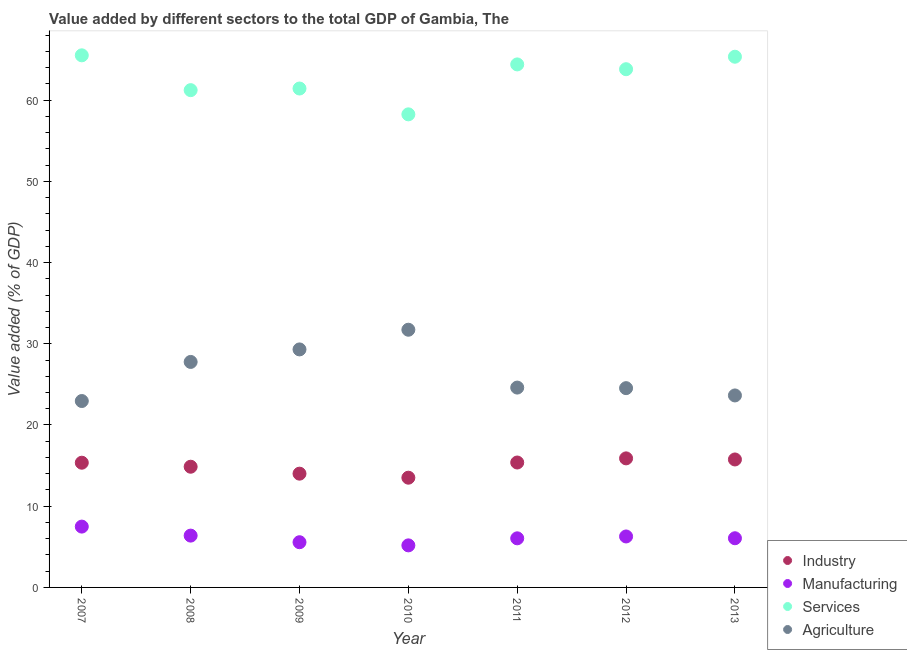Is the number of dotlines equal to the number of legend labels?
Provide a succinct answer. Yes. What is the value added by manufacturing sector in 2012?
Keep it short and to the point. 6.27. Across all years, what is the maximum value added by services sector?
Provide a short and direct response. 65.51. Across all years, what is the minimum value added by agricultural sector?
Your answer should be very brief. 22.95. In which year was the value added by industrial sector maximum?
Your response must be concise. 2012. In which year was the value added by services sector minimum?
Keep it short and to the point. 2010. What is the total value added by manufacturing sector in the graph?
Make the answer very short. 42.99. What is the difference between the value added by agricultural sector in 2011 and that in 2012?
Your answer should be compact. 0.07. What is the difference between the value added by services sector in 2013 and the value added by agricultural sector in 2009?
Offer a terse response. 36.04. What is the average value added by agricultural sector per year?
Your response must be concise. 26.36. In the year 2012, what is the difference between the value added by services sector and value added by agricultural sector?
Provide a short and direct response. 39.27. What is the ratio of the value added by services sector in 2008 to that in 2009?
Provide a succinct answer. 1. Is the difference between the value added by agricultural sector in 2008 and 2010 greater than the difference between the value added by services sector in 2008 and 2010?
Ensure brevity in your answer.  No. What is the difference between the highest and the second highest value added by services sector?
Offer a very short reply. 0.17. What is the difference between the highest and the lowest value added by manufacturing sector?
Ensure brevity in your answer.  2.31. In how many years, is the value added by industrial sector greater than the average value added by industrial sector taken over all years?
Your answer should be compact. 4. Is the sum of the value added by agricultural sector in 2008 and 2009 greater than the maximum value added by industrial sector across all years?
Provide a succinct answer. Yes. Is it the case that in every year, the sum of the value added by services sector and value added by industrial sector is greater than the sum of value added by agricultural sector and value added by manufacturing sector?
Your answer should be very brief. No. Does the value added by agricultural sector monotonically increase over the years?
Keep it short and to the point. No. How many dotlines are there?
Make the answer very short. 4. What is the difference between two consecutive major ticks on the Y-axis?
Your response must be concise. 10. Are the values on the major ticks of Y-axis written in scientific E-notation?
Your answer should be compact. No. What is the title of the graph?
Make the answer very short. Value added by different sectors to the total GDP of Gambia, The. What is the label or title of the Y-axis?
Your answer should be very brief. Value added (% of GDP). What is the Value added (% of GDP) of Industry in 2007?
Provide a short and direct response. 15.35. What is the Value added (% of GDP) in Manufacturing in 2007?
Make the answer very short. 7.49. What is the Value added (% of GDP) in Services in 2007?
Provide a succinct answer. 65.51. What is the Value added (% of GDP) in Agriculture in 2007?
Your response must be concise. 22.95. What is the Value added (% of GDP) of Industry in 2008?
Provide a succinct answer. 14.86. What is the Value added (% of GDP) of Manufacturing in 2008?
Your response must be concise. 6.38. What is the Value added (% of GDP) in Services in 2008?
Provide a succinct answer. 61.23. What is the Value added (% of GDP) of Agriculture in 2008?
Keep it short and to the point. 27.76. What is the Value added (% of GDP) in Industry in 2009?
Provide a short and direct response. 14.01. What is the Value added (% of GDP) in Manufacturing in 2009?
Provide a succinct answer. 5.57. What is the Value added (% of GDP) in Services in 2009?
Provide a short and direct response. 61.43. What is the Value added (% of GDP) of Agriculture in 2009?
Your response must be concise. 29.3. What is the Value added (% of GDP) in Industry in 2010?
Give a very brief answer. 13.51. What is the Value added (% of GDP) in Manufacturing in 2010?
Keep it short and to the point. 5.18. What is the Value added (% of GDP) in Services in 2010?
Offer a very short reply. 58.25. What is the Value added (% of GDP) of Agriculture in 2010?
Your response must be concise. 31.73. What is the Value added (% of GDP) in Industry in 2011?
Your response must be concise. 15.38. What is the Value added (% of GDP) in Manufacturing in 2011?
Your answer should be compact. 6.05. What is the Value added (% of GDP) in Services in 2011?
Offer a very short reply. 64.39. What is the Value added (% of GDP) of Agriculture in 2011?
Provide a succinct answer. 24.61. What is the Value added (% of GDP) of Industry in 2012?
Your response must be concise. 15.89. What is the Value added (% of GDP) of Manufacturing in 2012?
Offer a terse response. 6.27. What is the Value added (% of GDP) in Services in 2012?
Ensure brevity in your answer.  63.8. What is the Value added (% of GDP) in Agriculture in 2012?
Provide a short and direct response. 24.54. What is the Value added (% of GDP) of Industry in 2013?
Give a very brief answer. 15.75. What is the Value added (% of GDP) of Manufacturing in 2013?
Your answer should be very brief. 6.05. What is the Value added (% of GDP) of Services in 2013?
Your answer should be very brief. 65.34. What is the Value added (% of GDP) in Agriculture in 2013?
Keep it short and to the point. 23.64. Across all years, what is the maximum Value added (% of GDP) in Industry?
Your response must be concise. 15.89. Across all years, what is the maximum Value added (% of GDP) of Manufacturing?
Provide a succinct answer. 7.49. Across all years, what is the maximum Value added (% of GDP) of Services?
Offer a terse response. 65.51. Across all years, what is the maximum Value added (% of GDP) of Agriculture?
Make the answer very short. 31.73. Across all years, what is the minimum Value added (% of GDP) of Industry?
Your answer should be compact. 13.51. Across all years, what is the minimum Value added (% of GDP) in Manufacturing?
Offer a very short reply. 5.18. Across all years, what is the minimum Value added (% of GDP) of Services?
Ensure brevity in your answer.  58.25. Across all years, what is the minimum Value added (% of GDP) in Agriculture?
Make the answer very short. 22.95. What is the total Value added (% of GDP) of Industry in the graph?
Give a very brief answer. 104.76. What is the total Value added (% of GDP) of Manufacturing in the graph?
Provide a short and direct response. 42.99. What is the total Value added (% of GDP) of Services in the graph?
Your answer should be compact. 439.95. What is the total Value added (% of GDP) of Agriculture in the graph?
Keep it short and to the point. 184.52. What is the difference between the Value added (% of GDP) in Industry in 2007 and that in 2008?
Keep it short and to the point. 0.49. What is the difference between the Value added (% of GDP) of Manufacturing in 2007 and that in 2008?
Ensure brevity in your answer.  1.11. What is the difference between the Value added (% of GDP) in Services in 2007 and that in 2008?
Your answer should be very brief. 4.29. What is the difference between the Value added (% of GDP) in Agriculture in 2007 and that in 2008?
Provide a succinct answer. -4.81. What is the difference between the Value added (% of GDP) in Industry in 2007 and that in 2009?
Make the answer very short. 1.35. What is the difference between the Value added (% of GDP) of Manufacturing in 2007 and that in 2009?
Keep it short and to the point. 1.92. What is the difference between the Value added (% of GDP) in Services in 2007 and that in 2009?
Your answer should be compact. 4.09. What is the difference between the Value added (% of GDP) in Agriculture in 2007 and that in 2009?
Provide a succinct answer. -6.35. What is the difference between the Value added (% of GDP) of Industry in 2007 and that in 2010?
Make the answer very short. 1.84. What is the difference between the Value added (% of GDP) of Manufacturing in 2007 and that in 2010?
Keep it short and to the point. 2.31. What is the difference between the Value added (% of GDP) in Services in 2007 and that in 2010?
Your answer should be very brief. 7.27. What is the difference between the Value added (% of GDP) of Agriculture in 2007 and that in 2010?
Offer a terse response. -8.78. What is the difference between the Value added (% of GDP) of Industry in 2007 and that in 2011?
Provide a succinct answer. -0.03. What is the difference between the Value added (% of GDP) in Manufacturing in 2007 and that in 2011?
Keep it short and to the point. 1.44. What is the difference between the Value added (% of GDP) in Services in 2007 and that in 2011?
Ensure brevity in your answer.  1.12. What is the difference between the Value added (% of GDP) of Agriculture in 2007 and that in 2011?
Your response must be concise. -1.66. What is the difference between the Value added (% of GDP) of Industry in 2007 and that in 2012?
Ensure brevity in your answer.  -0.53. What is the difference between the Value added (% of GDP) of Manufacturing in 2007 and that in 2012?
Your response must be concise. 1.21. What is the difference between the Value added (% of GDP) in Services in 2007 and that in 2012?
Offer a terse response. 1.71. What is the difference between the Value added (% of GDP) of Agriculture in 2007 and that in 2012?
Offer a terse response. -1.59. What is the difference between the Value added (% of GDP) of Manufacturing in 2007 and that in 2013?
Give a very brief answer. 1.43. What is the difference between the Value added (% of GDP) of Services in 2007 and that in 2013?
Your answer should be compact. 0.17. What is the difference between the Value added (% of GDP) of Agriculture in 2007 and that in 2013?
Ensure brevity in your answer.  -0.69. What is the difference between the Value added (% of GDP) in Industry in 2008 and that in 2009?
Provide a short and direct response. 0.85. What is the difference between the Value added (% of GDP) in Manufacturing in 2008 and that in 2009?
Make the answer very short. 0.81. What is the difference between the Value added (% of GDP) of Services in 2008 and that in 2009?
Provide a succinct answer. -0.2. What is the difference between the Value added (% of GDP) in Agriculture in 2008 and that in 2009?
Your answer should be compact. -1.54. What is the difference between the Value added (% of GDP) of Industry in 2008 and that in 2010?
Your answer should be very brief. 1.35. What is the difference between the Value added (% of GDP) of Manufacturing in 2008 and that in 2010?
Your answer should be compact. 1.2. What is the difference between the Value added (% of GDP) in Services in 2008 and that in 2010?
Your answer should be very brief. 2.98. What is the difference between the Value added (% of GDP) of Agriculture in 2008 and that in 2010?
Your answer should be compact. -3.96. What is the difference between the Value added (% of GDP) in Industry in 2008 and that in 2011?
Provide a succinct answer. -0.52. What is the difference between the Value added (% of GDP) of Manufacturing in 2008 and that in 2011?
Make the answer very short. 0.33. What is the difference between the Value added (% of GDP) in Services in 2008 and that in 2011?
Your answer should be compact. -3.17. What is the difference between the Value added (% of GDP) in Agriculture in 2008 and that in 2011?
Your response must be concise. 3.16. What is the difference between the Value added (% of GDP) in Industry in 2008 and that in 2012?
Ensure brevity in your answer.  -1.03. What is the difference between the Value added (% of GDP) in Manufacturing in 2008 and that in 2012?
Give a very brief answer. 0.1. What is the difference between the Value added (% of GDP) in Services in 2008 and that in 2012?
Offer a very short reply. -2.58. What is the difference between the Value added (% of GDP) in Agriculture in 2008 and that in 2012?
Your answer should be very brief. 3.23. What is the difference between the Value added (% of GDP) in Industry in 2008 and that in 2013?
Your response must be concise. -0.89. What is the difference between the Value added (% of GDP) in Manufacturing in 2008 and that in 2013?
Your answer should be compact. 0.32. What is the difference between the Value added (% of GDP) of Services in 2008 and that in 2013?
Your answer should be compact. -4.11. What is the difference between the Value added (% of GDP) in Agriculture in 2008 and that in 2013?
Provide a succinct answer. 4.13. What is the difference between the Value added (% of GDP) of Industry in 2009 and that in 2010?
Give a very brief answer. 0.5. What is the difference between the Value added (% of GDP) in Manufacturing in 2009 and that in 2010?
Offer a very short reply. 0.39. What is the difference between the Value added (% of GDP) in Services in 2009 and that in 2010?
Your answer should be compact. 3.18. What is the difference between the Value added (% of GDP) of Agriculture in 2009 and that in 2010?
Give a very brief answer. -2.42. What is the difference between the Value added (% of GDP) of Industry in 2009 and that in 2011?
Provide a succinct answer. -1.37. What is the difference between the Value added (% of GDP) of Manufacturing in 2009 and that in 2011?
Provide a short and direct response. -0.48. What is the difference between the Value added (% of GDP) in Services in 2009 and that in 2011?
Offer a very short reply. -2.97. What is the difference between the Value added (% of GDP) in Agriculture in 2009 and that in 2011?
Your response must be concise. 4.7. What is the difference between the Value added (% of GDP) in Industry in 2009 and that in 2012?
Provide a succinct answer. -1.88. What is the difference between the Value added (% of GDP) in Manufacturing in 2009 and that in 2012?
Ensure brevity in your answer.  -0.71. What is the difference between the Value added (% of GDP) of Services in 2009 and that in 2012?
Give a very brief answer. -2.38. What is the difference between the Value added (% of GDP) in Agriculture in 2009 and that in 2012?
Your answer should be very brief. 4.77. What is the difference between the Value added (% of GDP) in Industry in 2009 and that in 2013?
Offer a very short reply. -1.75. What is the difference between the Value added (% of GDP) of Manufacturing in 2009 and that in 2013?
Offer a very short reply. -0.49. What is the difference between the Value added (% of GDP) in Services in 2009 and that in 2013?
Ensure brevity in your answer.  -3.91. What is the difference between the Value added (% of GDP) in Agriculture in 2009 and that in 2013?
Offer a very short reply. 5.67. What is the difference between the Value added (% of GDP) of Industry in 2010 and that in 2011?
Offer a terse response. -1.87. What is the difference between the Value added (% of GDP) in Manufacturing in 2010 and that in 2011?
Provide a short and direct response. -0.87. What is the difference between the Value added (% of GDP) of Services in 2010 and that in 2011?
Offer a very short reply. -6.15. What is the difference between the Value added (% of GDP) in Agriculture in 2010 and that in 2011?
Offer a very short reply. 7.12. What is the difference between the Value added (% of GDP) in Industry in 2010 and that in 2012?
Your response must be concise. -2.38. What is the difference between the Value added (% of GDP) in Manufacturing in 2010 and that in 2012?
Keep it short and to the point. -1.1. What is the difference between the Value added (% of GDP) of Services in 2010 and that in 2012?
Your answer should be compact. -5.56. What is the difference between the Value added (% of GDP) of Agriculture in 2010 and that in 2012?
Offer a very short reply. 7.19. What is the difference between the Value added (% of GDP) in Industry in 2010 and that in 2013?
Offer a terse response. -2.24. What is the difference between the Value added (% of GDP) in Manufacturing in 2010 and that in 2013?
Provide a short and direct response. -0.88. What is the difference between the Value added (% of GDP) of Services in 2010 and that in 2013?
Make the answer very short. -7.09. What is the difference between the Value added (% of GDP) of Agriculture in 2010 and that in 2013?
Offer a very short reply. 8.09. What is the difference between the Value added (% of GDP) of Industry in 2011 and that in 2012?
Provide a succinct answer. -0.51. What is the difference between the Value added (% of GDP) of Manufacturing in 2011 and that in 2012?
Make the answer very short. -0.23. What is the difference between the Value added (% of GDP) of Services in 2011 and that in 2012?
Provide a short and direct response. 0.59. What is the difference between the Value added (% of GDP) in Agriculture in 2011 and that in 2012?
Your answer should be very brief. 0.07. What is the difference between the Value added (% of GDP) of Industry in 2011 and that in 2013?
Provide a succinct answer. -0.37. What is the difference between the Value added (% of GDP) in Manufacturing in 2011 and that in 2013?
Offer a terse response. -0.01. What is the difference between the Value added (% of GDP) of Services in 2011 and that in 2013?
Make the answer very short. -0.95. What is the difference between the Value added (% of GDP) of Agriculture in 2011 and that in 2013?
Give a very brief answer. 0.97. What is the difference between the Value added (% of GDP) of Industry in 2012 and that in 2013?
Your response must be concise. 0.13. What is the difference between the Value added (% of GDP) of Manufacturing in 2012 and that in 2013?
Your answer should be compact. 0.22. What is the difference between the Value added (% of GDP) in Services in 2012 and that in 2013?
Provide a short and direct response. -1.54. What is the difference between the Value added (% of GDP) of Agriculture in 2012 and that in 2013?
Provide a succinct answer. 0.9. What is the difference between the Value added (% of GDP) of Industry in 2007 and the Value added (% of GDP) of Manufacturing in 2008?
Your answer should be very brief. 8.98. What is the difference between the Value added (% of GDP) of Industry in 2007 and the Value added (% of GDP) of Services in 2008?
Provide a short and direct response. -45.87. What is the difference between the Value added (% of GDP) of Industry in 2007 and the Value added (% of GDP) of Agriculture in 2008?
Give a very brief answer. -12.41. What is the difference between the Value added (% of GDP) of Manufacturing in 2007 and the Value added (% of GDP) of Services in 2008?
Your answer should be very brief. -53.74. What is the difference between the Value added (% of GDP) in Manufacturing in 2007 and the Value added (% of GDP) in Agriculture in 2008?
Keep it short and to the point. -20.27. What is the difference between the Value added (% of GDP) in Services in 2007 and the Value added (% of GDP) in Agriculture in 2008?
Offer a very short reply. 37.75. What is the difference between the Value added (% of GDP) of Industry in 2007 and the Value added (% of GDP) of Manufacturing in 2009?
Your answer should be compact. 9.79. What is the difference between the Value added (% of GDP) in Industry in 2007 and the Value added (% of GDP) in Services in 2009?
Offer a terse response. -46.07. What is the difference between the Value added (% of GDP) in Industry in 2007 and the Value added (% of GDP) in Agriculture in 2009?
Make the answer very short. -13.95. What is the difference between the Value added (% of GDP) in Manufacturing in 2007 and the Value added (% of GDP) in Services in 2009?
Your answer should be compact. -53.94. What is the difference between the Value added (% of GDP) of Manufacturing in 2007 and the Value added (% of GDP) of Agriculture in 2009?
Your response must be concise. -21.82. What is the difference between the Value added (% of GDP) of Services in 2007 and the Value added (% of GDP) of Agriculture in 2009?
Your answer should be compact. 36.21. What is the difference between the Value added (% of GDP) of Industry in 2007 and the Value added (% of GDP) of Manufacturing in 2010?
Offer a very short reply. 10.18. What is the difference between the Value added (% of GDP) of Industry in 2007 and the Value added (% of GDP) of Services in 2010?
Give a very brief answer. -42.89. What is the difference between the Value added (% of GDP) in Industry in 2007 and the Value added (% of GDP) in Agriculture in 2010?
Your answer should be compact. -16.37. What is the difference between the Value added (% of GDP) of Manufacturing in 2007 and the Value added (% of GDP) of Services in 2010?
Make the answer very short. -50.76. What is the difference between the Value added (% of GDP) in Manufacturing in 2007 and the Value added (% of GDP) in Agriculture in 2010?
Offer a terse response. -24.24. What is the difference between the Value added (% of GDP) of Services in 2007 and the Value added (% of GDP) of Agriculture in 2010?
Your answer should be compact. 33.79. What is the difference between the Value added (% of GDP) of Industry in 2007 and the Value added (% of GDP) of Manufacturing in 2011?
Offer a very short reply. 9.31. What is the difference between the Value added (% of GDP) in Industry in 2007 and the Value added (% of GDP) in Services in 2011?
Keep it short and to the point. -49.04. What is the difference between the Value added (% of GDP) in Industry in 2007 and the Value added (% of GDP) in Agriculture in 2011?
Make the answer very short. -9.25. What is the difference between the Value added (% of GDP) in Manufacturing in 2007 and the Value added (% of GDP) in Services in 2011?
Your answer should be compact. -56.91. What is the difference between the Value added (% of GDP) in Manufacturing in 2007 and the Value added (% of GDP) in Agriculture in 2011?
Provide a short and direct response. -17.12. What is the difference between the Value added (% of GDP) of Services in 2007 and the Value added (% of GDP) of Agriculture in 2011?
Ensure brevity in your answer.  40.91. What is the difference between the Value added (% of GDP) in Industry in 2007 and the Value added (% of GDP) in Manufacturing in 2012?
Give a very brief answer. 9.08. What is the difference between the Value added (% of GDP) in Industry in 2007 and the Value added (% of GDP) in Services in 2012?
Offer a very short reply. -48.45. What is the difference between the Value added (% of GDP) in Industry in 2007 and the Value added (% of GDP) in Agriculture in 2012?
Make the answer very short. -9.18. What is the difference between the Value added (% of GDP) in Manufacturing in 2007 and the Value added (% of GDP) in Services in 2012?
Offer a terse response. -56.31. What is the difference between the Value added (% of GDP) of Manufacturing in 2007 and the Value added (% of GDP) of Agriculture in 2012?
Offer a terse response. -17.05. What is the difference between the Value added (% of GDP) of Services in 2007 and the Value added (% of GDP) of Agriculture in 2012?
Provide a succinct answer. 40.98. What is the difference between the Value added (% of GDP) in Industry in 2007 and the Value added (% of GDP) in Manufacturing in 2013?
Provide a short and direct response. 9.3. What is the difference between the Value added (% of GDP) of Industry in 2007 and the Value added (% of GDP) of Services in 2013?
Offer a terse response. -49.99. What is the difference between the Value added (% of GDP) of Industry in 2007 and the Value added (% of GDP) of Agriculture in 2013?
Your answer should be very brief. -8.28. What is the difference between the Value added (% of GDP) of Manufacturing in 2007 and the Value added (% of GDP) of Services in 2013?
Your answer should be very brief. -57.85. What is the difference between the Value added (% of GDP) of Manufacturing in 2007 and the Value added (% of GDP) of Agriculture in 2013?
Offer a very short reply. -16.15. What is the difference between the Value added (% of GDP) of Services in 2007 and the Value added (% of GDP) of Agriculture in 2013?
Provide a short and direct response. 41.88. What is the difference between the Value added (% of GDP) of Industry in 2008 and the Value added (% of GDP) of Manufacturing in 2009?
Your answer should be very brief. 9.29. What is the difference between the Value added (% of GDP) in Industry in 2008 and the Value added (% of GDP) in Services in 2009?
Your response must be concise. -46.57. What is the difference between the Value added (% of GDP) in Industry in 2008 and the Value added (% of GDP) in Agriculture in 2009?
Your answer should be very brief. -14.44. What is the difference between the Value added (% of GDP) of Manufacturing in 2008 and the Value added (% of GDP) of Services in 2009?
Your answer should be compact. -55.05. What is the difference between the Value added (% of GDP) in Manufacturing in 2008 and the Value added (% of GDP) in Agriculture in 2009?
Give a very brief answer. -22.93. What is the difference between the Value added (% of GDP) in Services in 2008 and the Value added (% of GDP) in Agriculture in 2009?
Your answer should be compact. 31.92. What is the difference between the Value added (% of GDP) of Industry in 2008 and the Value added (% of GDP) of Manufacturing in 2010?
Your answer should be very brief. 9.68. What is the difference between the Value added (% of GDP) of Industry in 2008 and the Value added (% of GDP) of Services in 2010?
Give a very brief answer. -43.39. What is the difference between the Value added (% of GDP) in Industry in 2008 and the Value added (% of GDP) in Agriculture in 2010?
Offer a terse response. -16.87. What is the difference between the Value added (% of GDP) in Manufacturing in 2008 and the Value added (% of GDP) in Services in 2010?
Offer a very short reply. -51.87. What is the difference between the Value added (% of GDP) in Manufacturing in 2008 and the Value added (% of GDP) in Agriculture in 2010?
Give a very brief answer. -25.35. What is the difference between the Value added (% of GDP) of Services in 2008 and the Value added (% of GDP) of Agriculture in 2010?
Keep it short and to the point. 29.5. What is the difference between the Value added (% of GDP) in Industry in 2008 and the Value added (% of GDP) in Manufacturing in 2011?
Your response must be concise. 8.82. What is the difference between the Value added (% of GDP) of Industry in 2008 and the Value added (% of GDP) of Services in 2011?
Provide a succinct answer. -49.53. What is the difference between the Value added (% of GDP) in Industry in 2008 and the Value added (% of GDP) in Agriculture in 2011?
Provide a succinct answer. -9.75. What is the difference between the Value added (% of GDP) of Manufacturing in 2008 and the Value added (% of GDP) of Services in 2011?
Give a very brief answer. -58.01. What is the difference between the Value added (% of GDP) of Manufacturing in 2008 and the Value added (% of GDP) of Agriculture in 2011?
Offer a terse response. -18.23. What is the difference between the Value added (% of GDP) of Services in 2008 and the Value added (% of GDP) of Agriculture in 2011?
Your answer should be compact. 36.62. What is the difference between the Value added (% of GDP) of Industry in 2008 and the Value added (% of GDP) of Manufacturing in 2012?
Keep it short and to the point. 8.59. What is the difference between the Value added (% of GDP) of Industry in 2008 and the Value added (% of GDP) of Services in 2012?
Provide a short and direct response. -48.94. What is the difference between the Value added (% of GDP) of Industry in 2008 and the Value added (% of GDP) of Agriculture in 2012?
Keep it short and to the point. -9.68. What is the difference between the Value added (% of GDP) in Manufacturing in 2008 and the Value added (% of GDP) in Services in 2012?
Keep it short and to the point. -57.42. What is the difference between the Value added (% of GDP) in Manufacturing in 2008 and the Value added (% of GDP) in Agriculture in 2012?
Your response must be concise. -18.16. What is the difference between the Value added (% of GDP) in Services in 2008 and the Value added (% of GDP) in Agriculture in 2012?
Offer a terse response. 36.69. What is the difference between the Value added (% of GDP) in Industry in 2008 and the Value added (% of GDP) in Manufacturing in 2013?
Your answer should be very brief. 8.81. What is the difference between the Value added (% of GDP) of Industry in 2008 and the Value added (% of GDP) of Services in 2013?
Offer a terse response. -50.48. What is the difference between the Value added (% of GDP) of Industry in 2008 and the Value added (% of GDP) of Agriculture in 2013?
Your response must be concise. -8.78. What is the difference between the Value added (% of GDP) in Manufacturing in 2008 and the Value added (% of GDP) in Services in 2013?
Give a very brief answer. -58.96. What is the difference between the Value added (% of GDP) of Manufacturing in 2008 and the Value added (% of GDP) of Agriculture in 2013?
Ensure brevity in your answer.  -17.26. What is the difference between the Value added (% of GDP) in Services in 2008 and the Value added (% of GDP) in Agriculture in 2013?
Make the answer very short. 37.59. What is the difference between the Value added (% of GDP) of Industry in 2009 and the Value added (% of GDP) of Manufacturing in 2010?
Your response must be concise. 8.83. What is the difference between the Value added (% of GDP) of Industry in 2009 and the Value added (% of GDP) of Services in 2010?
Your answer should be very brief. -44.24. What is the difference between the Value added (% of GDP) of Industry in 2009 and the Value added (% of GDP) of Agriculture in 2010?
Keep it short and to the point. -17.72. What is the difference between the Value added (% of GDP) of Manufacturing in 2009 and the Value added (% of GDP) of Services in 2010?
Ensure brevity in your answer.  -52.68. What is the difference between the Value added (% of GDP) in Manufacturing in 2009 and the Value added (% of GDP) in Agriculture in 2010?
Keep it short and to the point. -26.16. What is the difference between the Value added (% of GDP) of Services in 2009 and the Value added (% of GDP) of Agriculture in 2010?
Offer a very short reply. 29.7. What is the difference between the Value added (% of GDP) in Industry in 2009 and the Value added (% of GDP) in Manufacturing in 2011?
Offer a terse response. 7.96. What is the difference between the Value added (% of GDP) in Industry in 2009 and the Value added (% of GDP) in Services in 2011?
Offer a very short reply. -50.39. What is the difference between the Value added (% of GDP) of Industry in 2009 and the Value added (% of GDP) of Agriculture in 2011?
Ensure brevity in your answer.  -10.6. What is the difference between the Value added (% of GDP) of Manufacturing in 2009 and the Value added (% of GDP) of Services in 2011?
Give a very brief answer. -58.83. What is the difference between the Value added (% of GDP) in Manufacturing in 2009 and the Value added (% of GDP) in Agriculture in 2011?
Provide a short and direct response. -19.04. What is the difference between the Value added (% of GDP) of Services in 2009 and the Value added (% of GDP) of Agriculture in 2011?
Give a very brief answer. 36.82. What is the difference between the Value added (% of GDP) in Industry in 2009 and the Value added (% of GDP) in Manufacturing in 2012?
Give a very brief answer. 7.73. What is the difference between the Value added (% of GDP) of Industry in 2009 and the Value added (% of GDP) of Services in 2012?
Make the answer very short. -49.8. What is the difference between the Value added (% of GDP) in Industry in 2009 and the Value added (% of GDP) in Agriculture in 2012?
Provide a short and direct response. -10.53. What is the difference between the Value added (% of GDP) in Manufacturing in 2009 and the Value added (% of GDP) in Services in 2012?
Your answer should be compact. -58.24. What is the difference between the Value added (% of GDP) in Manufacturing in 2009 and the Value added (% of GDP) in Agriculture in 2012?
Keep it short and to the point. -18.97. What is the difference between the Value added (% of GDP) of Services in 2009 and the Value added (% of GDP) of Agriculture in 2012?
Your answer should be compact. 36.89. What is the difference between the Value added (% of GDP) in Industry in 2009 and the Value added (% of GDP) in Manufacturing in 2013?
Give a very brief answer. 7.95. What is the difference between the Value added (% of GDP) in Industry in 2009 and the Value added (% of GDP) in Services in 2013?
Give a very brief answer. -51.33. What is the difference between the Value added (% of GDP) in Industry in 2009 and the Value added (% of GDP) in Agriculture in 2013?
Provide a succinct answer. -9.63. What is the difference between the Value added (% of GDP) in Manufacturing in 2009 and the Value added (% of GDP) in Services in 2013?
Provide a short and direct response. -59.77. What is the difference between the Value added (% of GDP) of Manufacturing in 2009 and the Value added (% of GDP) of Agriculture in 2013?
Your response must be concise. -18.07. What is the difference between the Value added (% of GDP) in Services in 2009 and the Value added (% of GDP) in Agriculture in 2013?
Offer a very short reply. 37.79. What is the difference between the Value added (% of GDP) in Industry in 2010 and the Value added (% of GDP) in Manufacturing in 2011?
Your response must be concise. 7.46. What is the difference between the Value added (% of GDP) of Industry in 2010 and the Value added (% of GDP) of Services in 2011?
Your answer should be very brief. -50.88. What is the difference between the Value added (% of GDP) of Industry in 2010 and the Value added (% of GDP) of Agriculture in 2011?
Make the answer very short. -11.1. What is the difference between the Value added (% of GDP) of Manufacturing in 2010 and the Value added (% of GDP) of Services in 2011?
Provide a short and direct response. -59.22. What is the difference between the Value added (% of GDP) of Manufacturing in 2010 and the Value added (% of GDP) of Agriculture in 2011?
Offer a terse response. -19.43. What is the difference between the Value added (% of GDP) of Services in 2010 and the Value added (% of GDP) of Agriculture in 2011?
Make the answer very short. 33.64. What is the difference between the Value added (% of GDP) of Industry in 2010 and the Value added (% of GDP) of Manufacturing in 2012?
Make the answer very short. 7.24. What is the difference between the Value added (% of GDP) of Industry in 2010 and the Value added (% of GDP) of Services in 2012?
Give a very brief answer. -50.29. What is the difference between the Value added (% of GDP) in Industry in 2010 and the Value added (% of GDP) in Agriculture in 2012?
Ensure brevity in your answer.  -11.03. What is the difference between the Value added (% of GDP) in Manufacturing in 2010 and the Value added (% of GDP) in Services in 2012?
Provide a short and direct response. -58.63. What is the difference between the Value added (% of GDP) of Manufacturing in 2010 and the Value added (% of GDP) of Agriculture in 2012?
Give a very brief answer. -19.36. What is the difference between the Value added (% of GDP) in Services in 2010 and the Value added (% of GDP) in Agriculture in 2012?
Provide a short and direct response. 33.71. What is the difference between the Value added (% of GDP) in Industry in 2010 and the Value added (% of GDP) in Manufacturing in 2013?
Ensure brevity in your answer.  7.46. What is the difference between the Value added (% of GDP) of Industry in 2010 and the Value added (% of GDP) of Services in 2013?
Provide a succinct answer. -51.83. What is the difference between the Value added (% of GDP) in Industry in 2010 and the Value added (% of GDP) in Agriculture in 2013?
Your response must be concise. -10.13. What is the difference between the Value added (% of GDP) in Manufacturing in 2010 and the Value added (% of GDP) in Services in 2013?
Offer a terse response. -60.16. What is the difference between the Value added (% of GDP) of Manufacturing in 2010 and the Value added (% of GDP) of Agriculture in 2013?
Your answer should be very brief. -18.46. What is the difference between the Value added (% of GDP) in Services in 2010 and the Value added (% of GDP) in Agriculture in 2013?
Provide a short and direct response. 34.61. What is the difference between the Value added (% of GDP) of Industry in 2011 and the Value added (% of GDP) of Manufacturing in 2012?
Offer a very short reply. 9.11. What is the difference between the Value added (% of GDP) of Industry in 2011 and the Value added (% of GDP) of Services in 2012?
Provide a short and direct response. -48.42. What is the difference between the Value added (% of GDP) of Industry in 2011 and the Value added (% of GDP) of Agriculture in 2012?
Make the answer very short. -9.16. What is the difference between the Value added (% of GDP) of Manufacturing in 2011 and the Value added (% of GDP) of Services in 2012?
Provide a succinct answer. -57.76. What is the difference between the Value added (% of GDP) of Manufacturing in 2011 and the Value added (% of GDP) of Agriculture in 2012?
Your answer should be compact. -18.49. What is the difference between the Value added (% of GDP) in Services in 2011 and the Value added (% of GDP) in Agriculture in 2012?
Your answer should be compact. 39.86. What is the difference between the Value added (% of GDP) in Industry in 2011 and the Value added (% of GDP) in Manufacturing in 2013?
Offer a very short reply. 9.33. What is the difference between the Value added (% of GDP) of Industry in 2011 and the Value added (% of GDP) of Services in 2013?
Keep it short and to the point. -49.96. What is the difference between the Value added (% of GDP) of Industry in 2011 and the Value added (% of GDP) of Agriculture in 2013?
Provide a short and direct response. -8.26. What is the difference between the Value added (% of GDP) in Manufacturing in 2011 and the Value added (% of GDP) in Services in 2013?
Your answer should be compact. -59.3. What is the difference between the Value added (% of GDP) in Manufacturing in 2011 and the Value added (% of GDP) in Agriculture in 2013?
Provide a succinct answer. -17.59. What is the difference between the Value added (% of GDP) in Services in 2011 and the Value added (% of GDP) in Agriculture in 2013?
Your answer should be compact. 40.76. What is the difference between the Value added (% of GDP) of Industry in 2012 and the Value added (% of GDP) of Manufacturing in 2013?
Ensure brevity in your answer.  9.83. What is the difference between the Value added (% of GDP) of Industry in 2012 and the Value added (% of GDP) of Services in 2013?
Your response must be concise. -49.45. What is the difference between the Value added (% of GDP) of Industry in 2012 and the Value added (% of GDP) of Agriculture in 2013?
Ensure brevity in your answer.  -7.75. What is the difference between the Value added (% of GDP) in Manufacturing in 2012 and the Value added (% of GDP) in Services in 2013?
Offer a terse response. -59.07. What is the difference between the Value added (% of GDP) in Manufacturing in 2012 and the Value added (% of GDP) in Agriculture in 2013?
Make the answer very short. -17.36. What is the difference between the Value added (% of GDP) of Services in 2012 and the Value added (% of GDP) of Agriculture in 2013?
Give a very brief answer. 40.17. What is the average Value added (% of GDP) of Industry per year?
Your answer should be very brief. 14.97. What is the average Value added (% of GDP) of Manufacturing per year?
Offer a very short reply. 6.14. What is the average Value added (% of GDP) in Services per year?
Give a very brief answer. 62.85. What is the average Value added (% of GDP) in Agriculture per year?
Your answer should be very brief. 26.36. In the year 2007, what is the difference between the Value added (% of GDP) of Industry and Value added (% of GDP) of Manufacturing?
Keep it short and to the point. 7.87. In the year 2007, what is the difference between the Value added (% of GDP) of Industry and Value added (% of GDP) of Services?
Make the answer very short. -50.16. In the year 2007, what is the difference between the Value added (% of GDP) of Industry and Value added (% of GDP) of Agriculture?
Give a very brief answer. -7.6. In the year 2007, what is the difference between the Value added (% of GDP) in Manufacturing and Value added (% of GDP) in Services?
Ensure brevity in your answer.  -58.02. In the year 2007, what is the difference between the Value added (% of GDP) of Manufacturing and Value added (% of GDP) of Agriculture?
Your answer should be compact. -15.46. In the year 2007, what is the difference between the Value added (% of GDP) in Services and Value added (% of GDP) in Agriculture?
Offer a very short reply. 42.56. In the year 2008, what is the difference between the Value added (% of GDP) of Industry and Value added (% of GDP) of Manufacturing?
Ensure brevity in your answer.  8.48. In the year 2008, what is the difference between the Value added (% of GDP) in Industry and Value added (% of GDP) in Services?
Keep it short and to the point. -46.37. In the year 2008, what is the difference between the Value added (% of GDP) of Industry and Value added (% of GDP) of Agriculture?
Your answer should be very brief. -12.9. In the year 2008, what is the difference between the Value added (% of GDP) in Manufacturing and Value added (% of GDP) in Services?
Ensure brevity in your answer.  -54.85. In the year 2008, what is the difference between the Value added (% of GDP) of Manufacturing and Value added (% of GDP) of Agriculture?
Give a very brief answer. -21.38. In the year 2008, what is the difference between the Value added (% of GDP) of Services and Value added (% of GDP) of Agriculture?
Keep it short and to the point. 33.46. In the year 2009, what is the difference between the Value added (% of GDP) in Industry and Value added (% of GDP) in Manufacturing?
Your answer should be compact. 8.44. In the year 2009, what is the difference between the Value added (% of GDP) of Industry and Value added (% of GDP) of Services?
Offer a very short reply. -47.42. In the year 2009, what is the difference between the Value added (% of GDP) in Industry and Value added (% of GDP) in Agriculture?
Provide a short and direct response. -15.3. In the year 2009, what is the difference between the Value added (% of GDP) in Manufacturing and Value added (% of GDP) in Services?
Provide a succinct answer. -55.86. In the year 2009, what is the difference between the Value added (% of GDP) in Manufacturing and Value added (% of GDP) in Agriculture?
Ensure brevity in your answer.  -23.74. In the year 2009, what is the difference between the Value added (% of GDP) in Services and Value added (% of GDP) in Agriculture?
Keep it short and to the point. 32.12. In the year 2010, what is the difference between the Value added (% of GDP) in Industry and Value added (% of GDP) in Manufacturing?
Make the answer very short. 8.33. In the year 2010, what is the difference between the Value added (% of GDP) in Industry and Value added (% of GDP) in Services?
Make the answer very short. -44.74. In the year 2010, what is the difference between the Value added (% of GDP) in Industry and Value added (% of GDP) in Agriculture?
Your answer should be very brief. -18.22. In the year 2010, what is the difference between the Value added (% of GDP) in Manufacturing and Value added (% of GDP) in Services?
Your answer should be compact. -53.07. In the year 2010, what is the difference between the Value added (% of GDP) of Manufacturing and Value added (% of GDP) of Agriculture?
Provide a short and direct response. -26.55. In the year 2010, what is the difference between the Value added (% of GDP) of Services and Value added (% of GDP) of Agriculture?
Ensure brevity in your answer.  26.52. In the year 2011, what is the difference between the Value added (% of GDP) of Industry and Value added (% of GDP) of Manufacturing?
Make the answer very short. 9.33. In the year 2011, what is the difference between the Value added (% of GDP) in Industry and Value added (% of GDP) in Services?
Your answer should be very brief. -49.01. In the year 2011, what is the difference between the Value added (% of GDP) in Industry and Value added (% of GDP) in Agriculture?
Offer a very short reply. -9.23. In the year 2011, what is the difference between the Value added (% of GDP) in Manufacturing and Value added (% of GDP) in Services?
Give a very brief answer. -58.35. In the year 2011, what is the difference between the Value added (% of GDP) in Manufacturing and Value added (% of GDP) in Agriculture?
Give a very brief answer. -18.56. In the year 2011, what is the difference between the Value added (% of GDP) in Services and Value added (% of GDP) in Agriculture?
Provide a short and direct response. 39.79. In the year 2012, what is the difference between the Value added (% of GDP) in Industry and Value added (% of GDP) in Manufacturing?
Offer a very short reply. 9.61. In the year 2012, what is the difference between the Value added (% of GDP) of Industry and Value added (% of GDP) of Services?
Offer a terse response. -47.91. In the year 2012, what is the difference between the Value added (% of GDP) in Industry and Value added (% of GDP) in Agriculture?
Offer a very short reply. -8.65. In the year 2012, what is the difference between the Value added (% of GDP) of Manufacturing and Value added (% of GDP) of Services?
Ensure brevity in your answer.  -57.53. In the year 2012, what is the difference between the Value added (% of GDP) in Manufacturing and Value added (% of GDP) in Agriculture?
Keep it short and to the point. -18.26. In the year 2012, what is the difference between the Value added (% of GDP) in Services and Value added (% of GDP) in Agriculture?
Ensure brevity in your answer.  39.27. In the year 2013, what is the difference between the Value added (% of GDP) of Industry and Value added (% of GDP) of Manufacturing?
Provide a short and direct response. 9.7. In the year 2013, what is the difference between the Value added (% of GDP) in Industry and Value added (% of GDP) in Services?
Your response must be concise. -49.59. In the year 2013, what is the difference between the Value added (% of GDP) of Industry and Value added (% of GDP) of Agriculture?
Ensure brevity in your answer.  -7.88. In the year 2013, what is the difference between the Value added (% of GDP) in Manufacturing and Value added (% of GDP) in Services?
Give a very brief answer. -59.29. In the year 2013, what is the difference between the Value added (% of GDP) in Manufacturing and Value added (% of GDP) in Agriculture?
Your answer should be very brief. -17.58. In the year 2013, what is the difference between the Value added (% of GDP) of Services and Value added (% of GDP) of Agriculture?
Provide a short and direct response. 41.7. What is the ratio of the Value added (% of GDP) in Industry in 2007 to that in 2008?
Keep it short and to the point. 1.03. What is the ratio of the Value added (% of GDP) of Manufacturing in 2007 to that in 2008?
Your response must be concise. 1.17. What is the ratio of the Value added (% of GDP) in Services in 2007 to that in 2008?
Offer a very short reply. 1.07. What is the ratio of the Value added (% of GDP) of Agriculture in 2007 to that in 2008?
Your answer should be very brief. 0.83. What is the ratio of the Value added (% of GDP) of Industry in 2007 to that in 2009?
Give a very brief answer. 1.1. What is the ratio of the Value added (% of GDP) in Manufacturing in 2007 to that in 2009?
Keep it short and to the point. 1.35. What is the ratio of the Value added (% of GDP) in Services in 2007 to that in 2009?
Give a very brief answer. 1.07. What is the ratio of the Value added (% of GDP) of Agriculture in 2007 to that in 2009?
Keep it short and to the point. 0.78. What is the ratio of the Value added (% of GDP) in Industry in 2007 to that in 2010?
Offer a terse response. 1.14. What is the ratio of the Value added (% of GDP) in Manufacturing in 2007 to that in 2010?
Offer a terse response. 1.45. What is the ratio of the Value added (% of GDP) in Services in 2007 to that in 2010?
Ensure brevity in your answer.  1.12. What is the ratio of the Value added (% of GDP) of Agriculture in 2007 to that in 2010?
Keep it short and to the point. 0.72. What is the ratio of the Value added (% of GDP) in Industry in 2007 to that in 2011?
Make the answer very short. 1. What is the ratio of the Value added (% of GDP) in Manufacturing in 2007 to that in 2011?
Keep it short and to the point. 1.24. What is the ratio of the Value added (% of GDP) of Services in 2007 to that in 2011?
Your answer should be compact. 1.02. What is the ratio of the Value added (% of GDP) of Agriculture in 2007 to that in 2011?
Your response must be concise. 0.93. What is the ratio of the Value added (% of GDP) of Industry in 2007 to that in 2012?
Make the answer very short. 0.97. What is the ratio of the Value added (% of GDP) of Manufacturing in 2007 to that in 2012?
Keep it short and to the point. 1.19. What is the ratio of the Value added (% of GDP) in Services in 2007 to that in 2012?
Your response must be concise. 1.03. What is the ratio of the Value added (% of GDP) of Agriculture in 2007 to that in 2012?
Offer a terse response. 0.94. What is the ratio of the Value added (% of GDP) in Industry in 2007 to that in 2013?
Provide a succinct answer. 0.97. What is the ratio of the Value added (% of GDP) in Manufacturing in 2007 to that in 2013?
Your answer should be compact. 1.24. What is the ratio of the Value added (% of GDP) in Agriculture in 2007 to that in 2013?
Offer a very short reply. 0.97. What is the ratio of the Value added (% of GDP) in Industry in 2008 to that in 2009?
Your answer should be very brief. 1.06. What is the ratio of the Value added (% of GDP) of Manufacturing in 2008 to that in 2009?
Ensure brevity in your answer.  1.15. What is the ratio of the Value added (% of GDP) of Industry in 2008 to that in 2010?
Your answer should be very brief. 1.1. What is the ratio of the Value added (% of GDP) of Manufacturing in 2008 to that in 2010?
Your response must be concise. 1.23. What is the ratio of the Value added (% of GDP) of Services in 2008 to that in 2010?
Your response must be concise. 1.05. What is the ratio of the Value added (% of GDP) of Agriculture in 2008 to that in 2010?
Your response must be concise. 0.88. What is the ratio of the Value added (% of GDP) in Industry in 2008 to that in 2011?
Keep it short and to the point. 0.97. What is the ratio of the Value added (% of GDP) in Manufacturing in 2008 to that in 2011?
Offer a terse response. 1.06. What is the ratio of the Value added (% of GDP) in Services in 2008 to that in 2011?
Your answer should be very brief. 0.95. What is the ratio of the Value added (% of GDP) of Agriculture in 2008 to that in 2011?
Keep it short and to the point. 1.13. What is the ratio of the Value added (% of GDP) in Industry in 2008 to that in 2012?
Offer a very short reply. 0.94. What is the ratio of the Value added (% of GDP) of Manufacturing in 2008 to that in 2012?
Your answer should be very brief. 1.02. What is the ratio of the Value added (% of GDP) of Services in 2008 to that in 2012?
Give a very brief answer. 0.96. What is the ratio of the Value added (% of GDP) of Agriculture in 2008 to that in 2012?
Keep it short and to the point. 1.13. What is the ratio of the Value added (% of GDP) in Industry in 2008 to that in 2013?
Your answer should be very brief. 0.94. What is the ratio of the Value added (% of GDP) of Manufacturing in 2008 to that in 2013?
Your answer should be very brief. 1.05. What is the ratio of the Value added (% of GDP) of Services in 2008 to that in 2013?
Your answer should be compact. 0.94. What is the ratio of the Value added (% of GDP) in Agriculture in 2008 to that in 2013?
Give a very brief answer. 1.17. What is the ratio of the Value added (% of GDP) of Industry in 2009 to that in 2010?
Ensure brevity in your answer.  1.04. What is the ratio of the Value added (% of GDP) of Manufacturing in 2009 to that in 2010?
Ensure brevity in your answer.  1.07. What is the ratio of the Value added (% of GDP) in Services in 2009 to that in 2010?
Your answer should be compact. 1.05. What is the ratio of the Value added (% of GDP) in Agriculture in 2009 to that in 2010?
Your answer should be compact. 0.92. What is the ratio of the Value added (% of GDP) of Industry in 2009 to that in 2011?
Give a very brief answer. 0.91. What is the ratio of the Value added (% of GDP) of Manufacturing in 2009 to that in 2011?
Offer a very short reply. 0.92. What is the ratio of the Value added (% of GDP) of Services in 2009 to that in 2011?
Provide a short and direct response. 0.95. What is the ratio of the Value added (% of GDP) of Agriculture in 2009 to that in 2011?
Offer a terse response. 1.19. What is the ratio of the Value added (% of GDP) in Industry in 2009 to that in 2012?
Your response must be concise. 0.88. What is the ratio of the Value added (% of GDP) of Manufacturing in 2009 to that in 2012?
Keep it short and to the point. 0.89. What is the ratio of the Value added (% of GDP) in Services in 2009 to that in 2012?
Ensure brevity in your answer.  0.96. What is the ratio of the Value added (% of GDP) of Agriculture in 2009 to that in 2012?
Offer a terse response. 1.19. What is the ratio of the Value added (% of GDP) in Industry in 2009 to that in 2013?
Your response must be concise. 0.89. What is the ratio of the Value added (% of GDP) of Manufacturing in 2009 to that in 2013?
Provide a short and direct response. 0.92. What is the ratio of the Value added (% of GDP) in Services in 2009 to that in 2013?
Your answer should be very brief. 0.94. What is the ratio of the Value added (% of GDP) of Agriculture in 2009 to that in 2013?
Provide a short and direct response. 1.24. What is the ratio of the Value added (% of GDP) in Industry in 2010 to that in 2011?
Your answer should be compact. 0.88. What is the ratio of the Value added (% of GDP) of Manufacturing in 2010 to that in 2011?
Your answer should be compact. 0.86. What is the ratio of the Value added (% of GDP) of Services in 2010 to that in 2011?
Offer a very short reply. 0.9. What is the ratio of the Value added (% of GDP) in Agriculture in 2010 to that in 2011?
Offer a very short reply. 1.29. What is the ratio of the Value added (% of GDP) in Industry in 2010 to that in 2012?
Give a very brief answer. 0.85. What is the ratio of the Value added (% of GDP) in Manufacturing in 2010 to that in 2012?
Your answer should be very brief. 0.83. What is the ratio of the Value added (% of GDP) in Services in 2010 to that in 2012?
Provide a short and direct response. 0.91. What is the ratio of the Value added (% of GDP) in Agriculture in 2010 to that in 2012?
Your answer should be very brief. 1.29. What is the ratio of the Value added (% of GDP) of Industry in 2010 to that in 2013?
Offer a very short reply. 0.86. What is the ratio of the Value added (% of GDP) in Manufacturing in 2010 to that in 2013?
Keep it short and to the point. 0.86. What is the ratio of the Value added (% of GDP) of Services in 2010 to that in 2013?
Offer a very short reply. 0.89. What is the ratio of the Value added (% of GDP) in Agriculture in 2010 to that in 2013?
Ensure brevity in your answer.  1.34. What is the ratio of the Value added (% of GDP) of Industry in 2011 to that in 2012?
Your response must be concise. 0.97. What is the ratio of the Value added (% of GDP) in Manufacturing in 2011 to that in 2012?
Make the answer very short. 0.96. What is the ratio of the Value added (% of GDP) of Services in 2011 to that in 2012?
Keep it short and to the point. 1.01. What is the ratio of the Value added (% of GDP) in Agriculture in 2011 to that in 2012?
Offer a terse response. 1. What is the ratio of the Value added (% of GDP) of Industry in 2011 to that in 2013?
Your answer should be very brief. 0.98. What is the ratio of the Value added (% of GDP) of Manufacturing in 2011 to that in 2013?
Your answer should be compact. 1. What is the ratio of the Value added (% of GDP) in Services in 2011 to that in 2013?
Offer a very short reply. 0.99. What is the ratio of the Value added (% of GDP) of Agriculture in 2011 to that in 2013?
Give a very brief answer. 1.04. What is the ratio of the Value added (% of GDP) in Industry in 2012 to that in 2013?
Give a very brief answer. 1.01. What is the ratio of the Value added (% of GDP) in Manufacturing in 2012 to that in 2013?
Provide a short and direct response. 1.04. What is the ratio of the Value added (% of GDP) in Services in 2012 to that in 2013?
Provide a short and direct response. 0.98. What is the ratio of the Value added (% of GDP) in Agriculture in 2012 to that in 2013?
Give a very brief answer. 1.04. What is the difference between the highest and the second highest Value added (% of GDP) of Industry?
Provide a succinct answer. 0.13. What is the difference between the highest and the second highest Value added (% of GDP) in Manufacturing?
Your response must be concise. 1.11. What is the difference between the highest and the second highest Value added (% of GDP) in Services?
Ensure brevity in your answer.  0.17. What is the difference between the highest and the second highest Value added (% of GDP) of Agriculture?
Your answer should be compact. 2.42. What is the difference between the highest and the lowest Value added (% of GDP) of Industry?
Make the answer very short. 2.38. What is the difference between the highest and the lowest Value added (% of GDP) of Manufacturing?
Your answer should be compact. 2.31. What is the difference between the highest and the lowest Value added (% of GDP) in Services?
Give a very brief answer. 7.27. What is the difference between the highest and the lowest Value added (% of GDP) of Agriculture?
Provide a succinct answer. 8.78. 